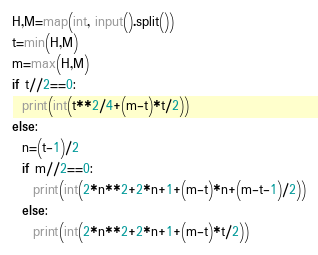Convert code to text. <code><loc_0><loc_0><loc_500><loc_500><_Python_>H,M=map(int, input().split())
t=min(H,M)
m=max(H,M)
if t//2==0:
  print(int(t**2/4+(m-t)*t/2)) 
else:
  n=(t-1)/2
  if m//2==0:
    print(int(2*n**2+2*n+1+(m-t)*n+(m-t-1)/2))
  else:
    print(int(2*n**2+2*n+1+(m-t)*t/2))</code> 